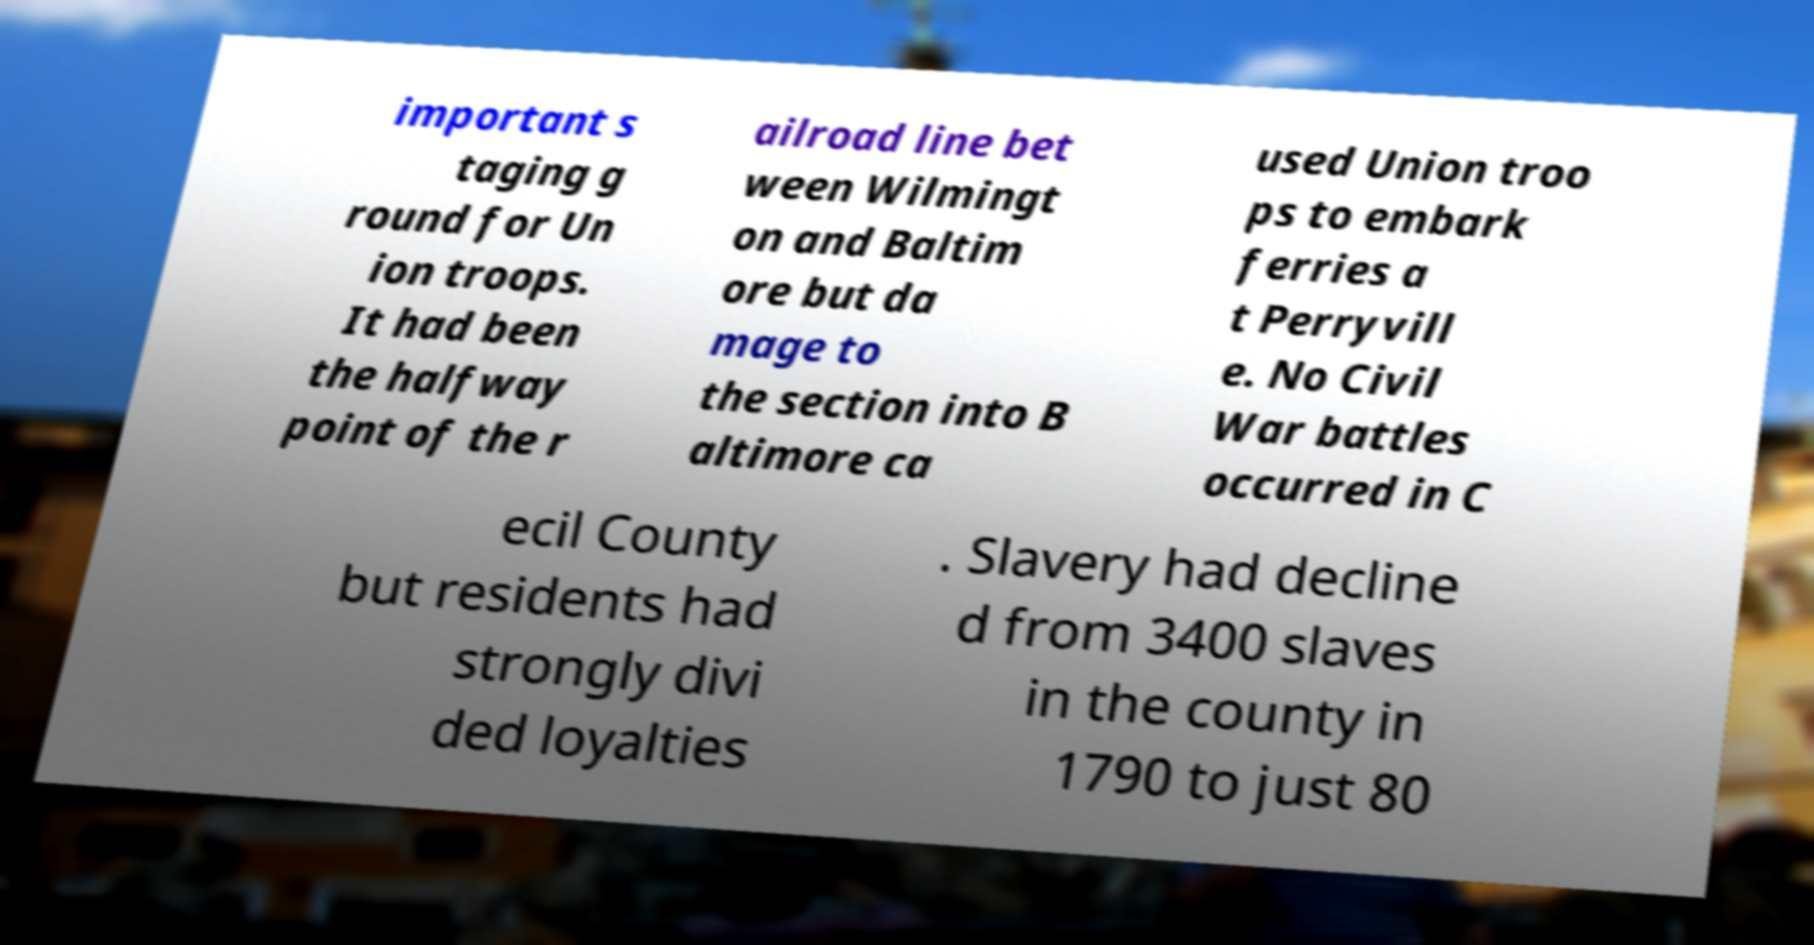I need the written content from this picture converted into text. Can you do that? important s taging g round for Un ion troops. It had been the halfway point of the r ailroad line bet ween Wilmingt on and Baltim ore but da mage to the section into B altimore ca used Union troo ps to embark ferries a t Perryvill e. No Civil War battles occurred in C ecil County but residents had strongly divi ded loyalties . Slavery had decline d from 3400 slaves in the county in 1790 to just 80 